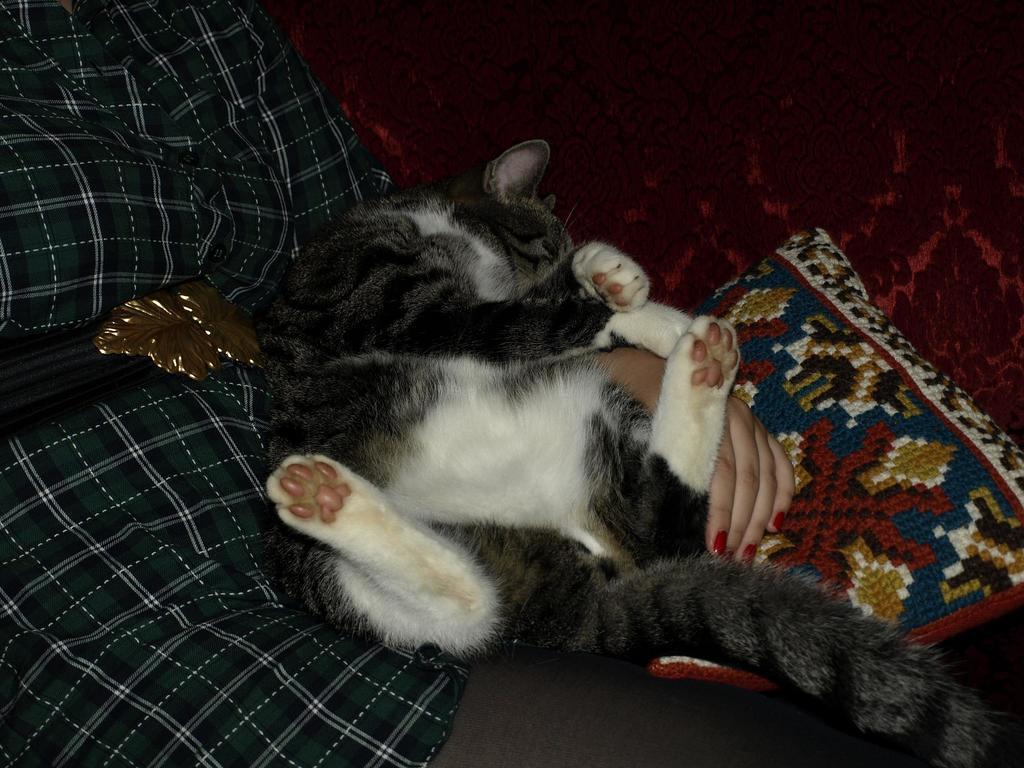Could you give a brief overview of what you see in this image? In this image we can see a person sitting on the sofa and there is a cat. We can see a cushion placed in the sofa. 